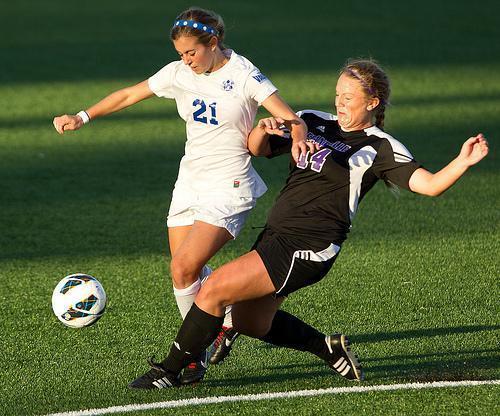How many people are in this picture?
Give a very brief answer. 2. 